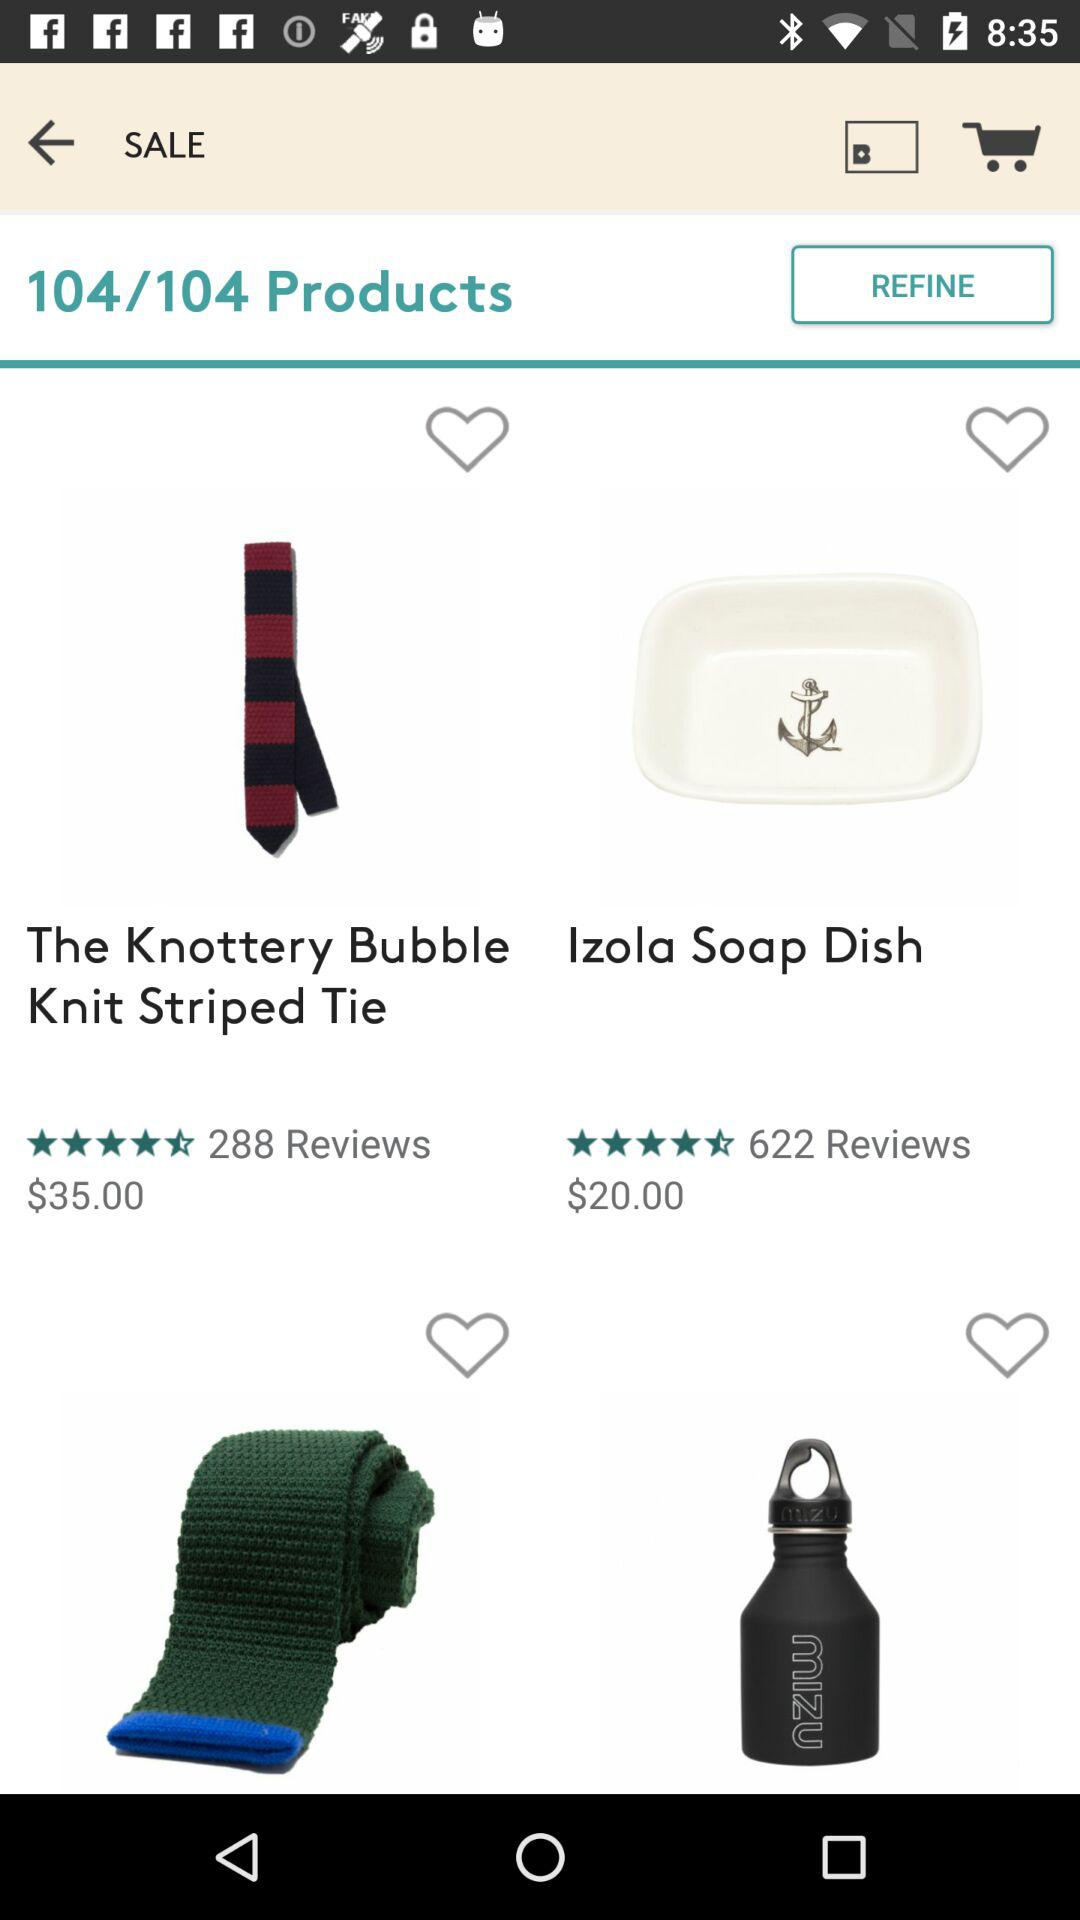What is the price of "The Knottery Bubble Knit Striped Tie"? The price of "The Knottery Bubble Knit Striped Tie" is $35. 